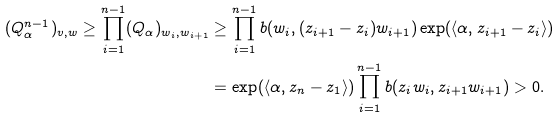<formula> <loc_0><loc_0><loc_500><loc_500>( Q _ { \alpha } ^ { n - 1 } ) _ { v , w } \geq \prod _ { i = 1 } ^ { n - 1 } ( Q _ { \alpha } ) _ { w _ { i } , w _ { i + 1 } } & \geq \prod _ { i = 1 } ^ { n - 1 } b ( w _ { i } , ( z _ { i + 1 } - z _ { i } ) w _ { i + 1 } ) \exp ( \langle \alpha , z _ { i + 1 } - z _ { i } \rangle ) \\ & = \exp ( \langle \alpha , z _ { n } - z _ { 1 } \rangle ) \prod _ { i = 1 } ^ { n - 1 } b ( z _ { i } w _ { i } , z _ { i + 1 } w _ { i + 1 } ) > 0 .</formula> 